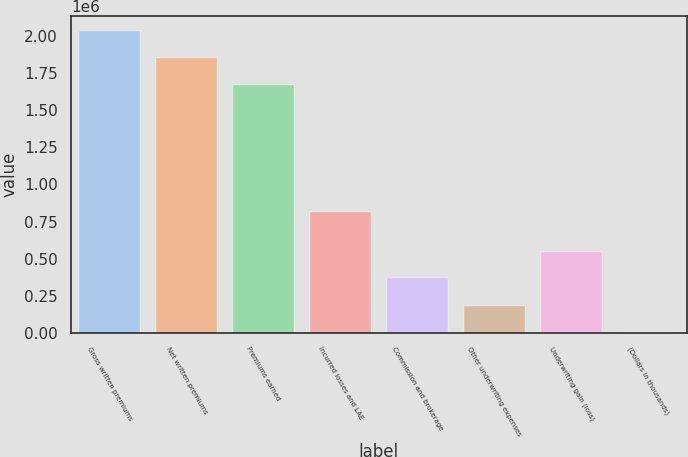Convert chart. <chart><loc_0><loc_0><loc_500><loc_500><bar_chart><fcel>Gross written premiums<fcel>Net written premiums<fcel>Premiums earned<fcel>Incurred losses and LAE<fcel>Commission and brokerage<fcel>Other underwriting expenses<fcel>Underwriting gain (loss)<fcel>(Dollars in thousands)<nl><fcel>2.03304e+06<fcel>1.85228e+06<fcel>1.67151e+06<fcel>814668<fcel>366890<fcel>182779<fcel>547656<fcel>2013<nl></chart> 